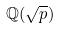<formula> <loc_0><loc_0><loc_500><loc_500>\mathbb { Q } ( \sqrt { p } )</formula> 